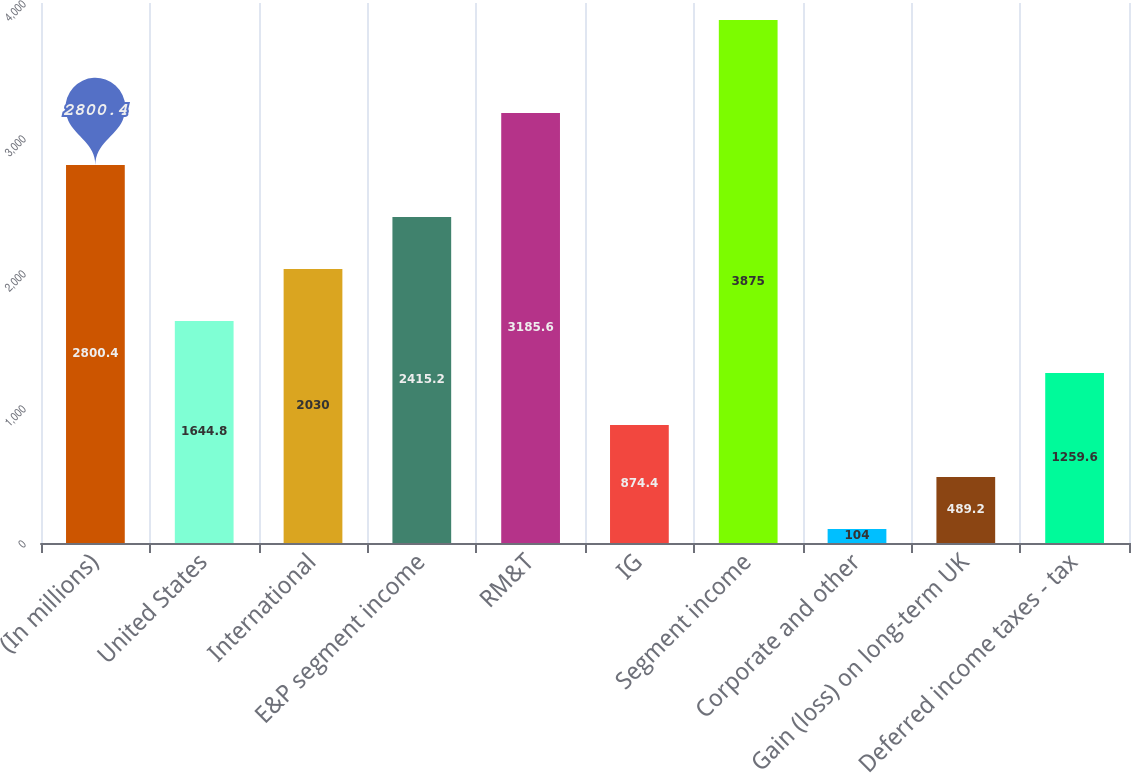<chart> <loc_0><loc_0><loc_500><loc_500><bar_chart><fcel>(In millions)<fcel>United States<fcel>International<fcel>E&P segment income<fcel>RM&T<fcel>IG<fcel>Segment income<fcel>Corporate and other<fcel>Gain (loss) on long-term UK<fcel>Deferred income taxes - tax<nl><fcel>2800.4<fcel>1644.8<fcel>2030<fcel>2415.2<fcel>3185.6<fcel>874.4<fcel>3875<fcel>104<fcel>489.2<fcel>1259.6<nl></chart> 